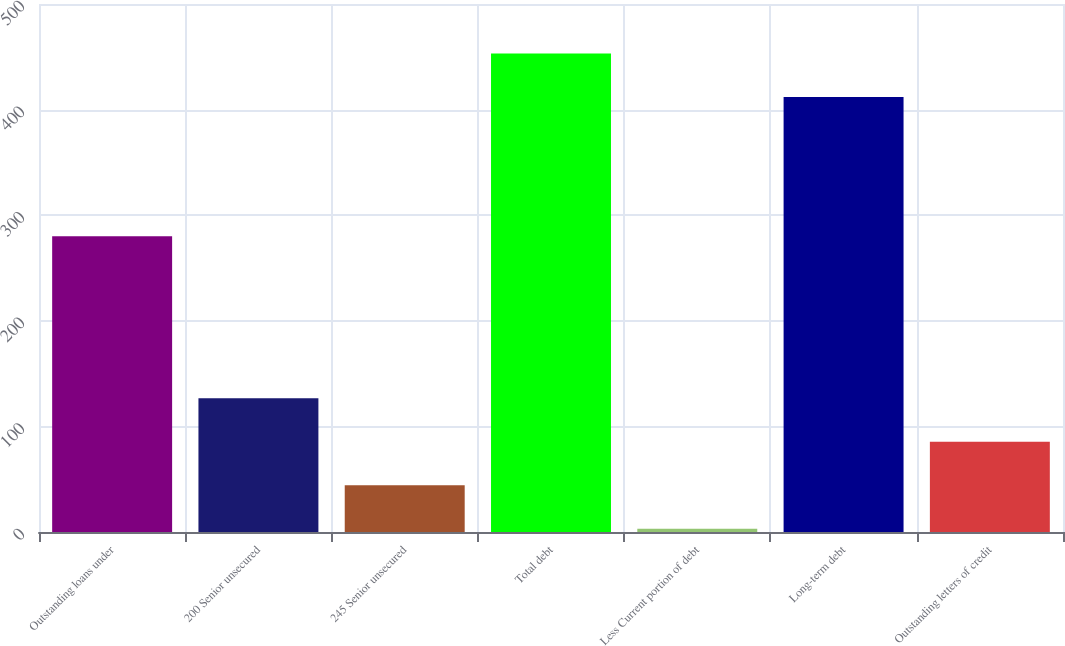<chart> <loc_0><loc_0><loc_500><loc_500><bar_chart><fcel>Outstanding loans under<fcel>200 Senior unsecured<fcel>245 Senior unsecured<fcel>Total debt<fcel>Less Current portion of debt<fcel>Long-term debt<fcel>Outstanding letters of credit<nl><fcel>280<fcel>126.6<fcel>44.2<fcel>453.2<fcel>3<fcel>412<fcel>85.4<nl></chart> 